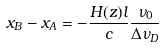Convert formula to latex. <formula><loc_0><loc_0><loc_500><loc_500>x _ { B } - x _ { A } = - \frac { H ( z ) l } { c } \frac { \nu _ { 0 } } { \Delta \nu _ { D } }</formula> 